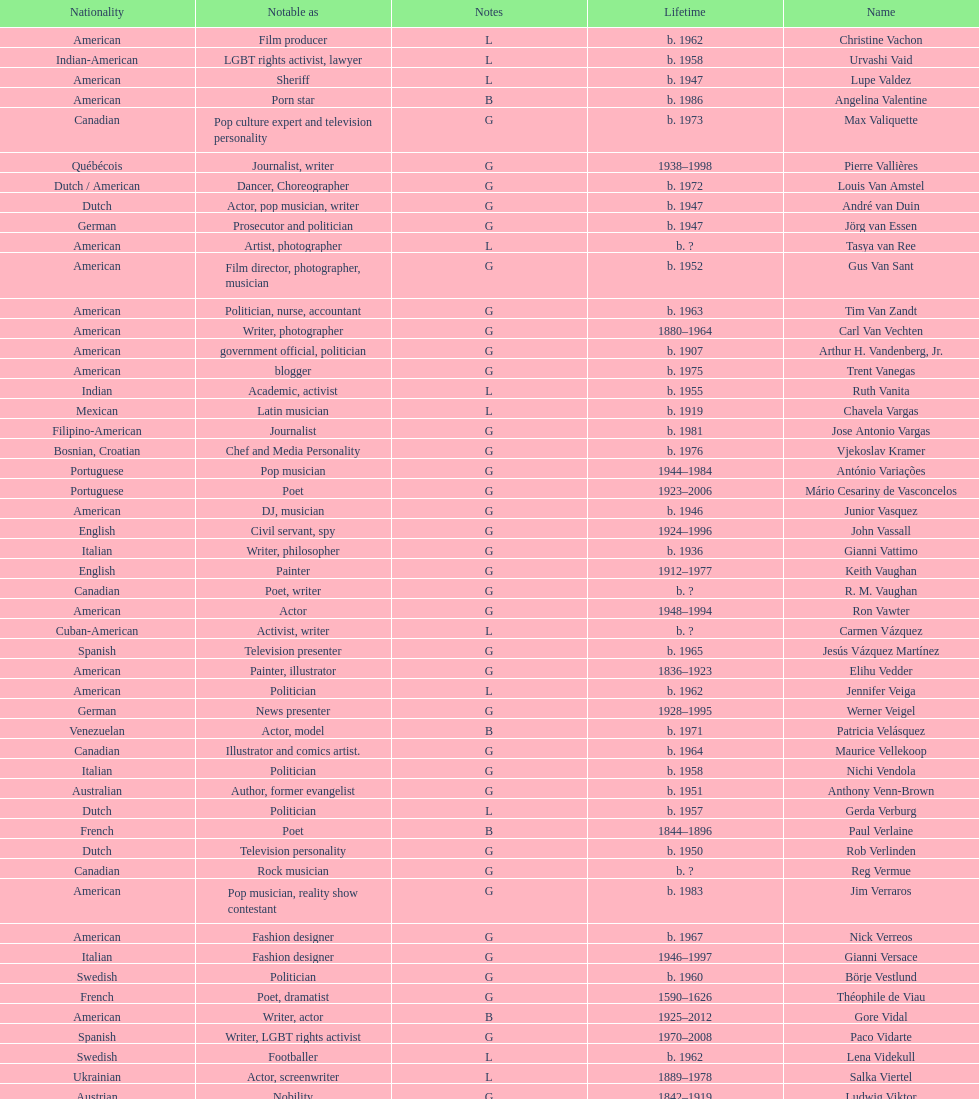What is the difference in year of borth between vachon and vaid? 4 years. 